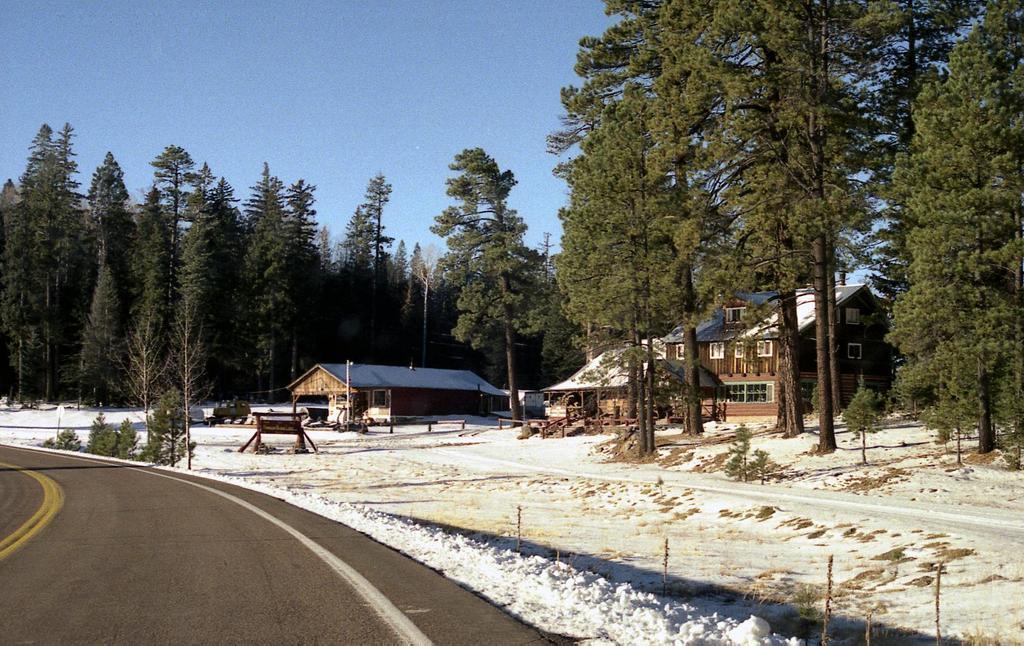In one or two sentences, can you explain what this image depicts? In the image we can see there are many trees, buildings, windows of the building and snow white in color. There is a road, white and yellow lines on the road, and a blue sky. 